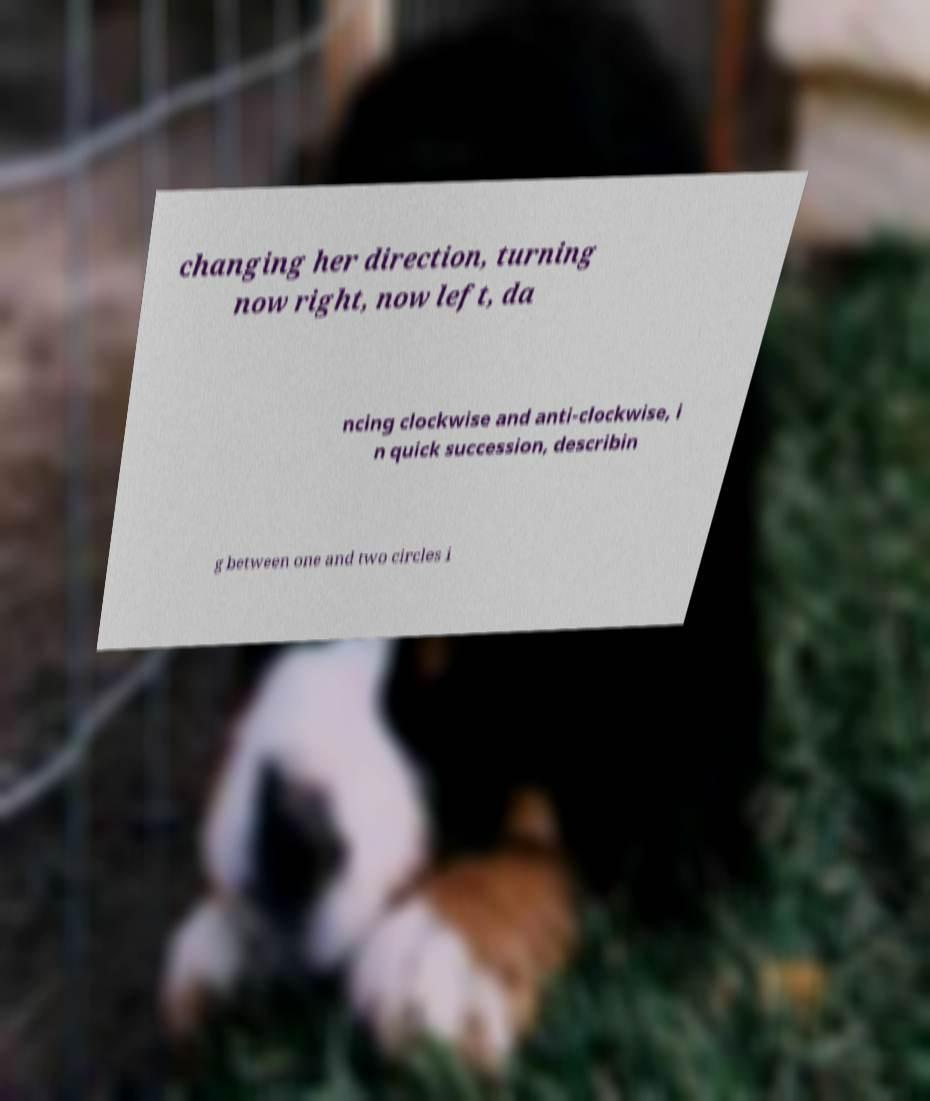Please identify and transcribe the text found in this image. changing her direction, turning now right, now left, da ncing clockwise and anti-clockwise, i n quick succession, describin g between one and two circles i 